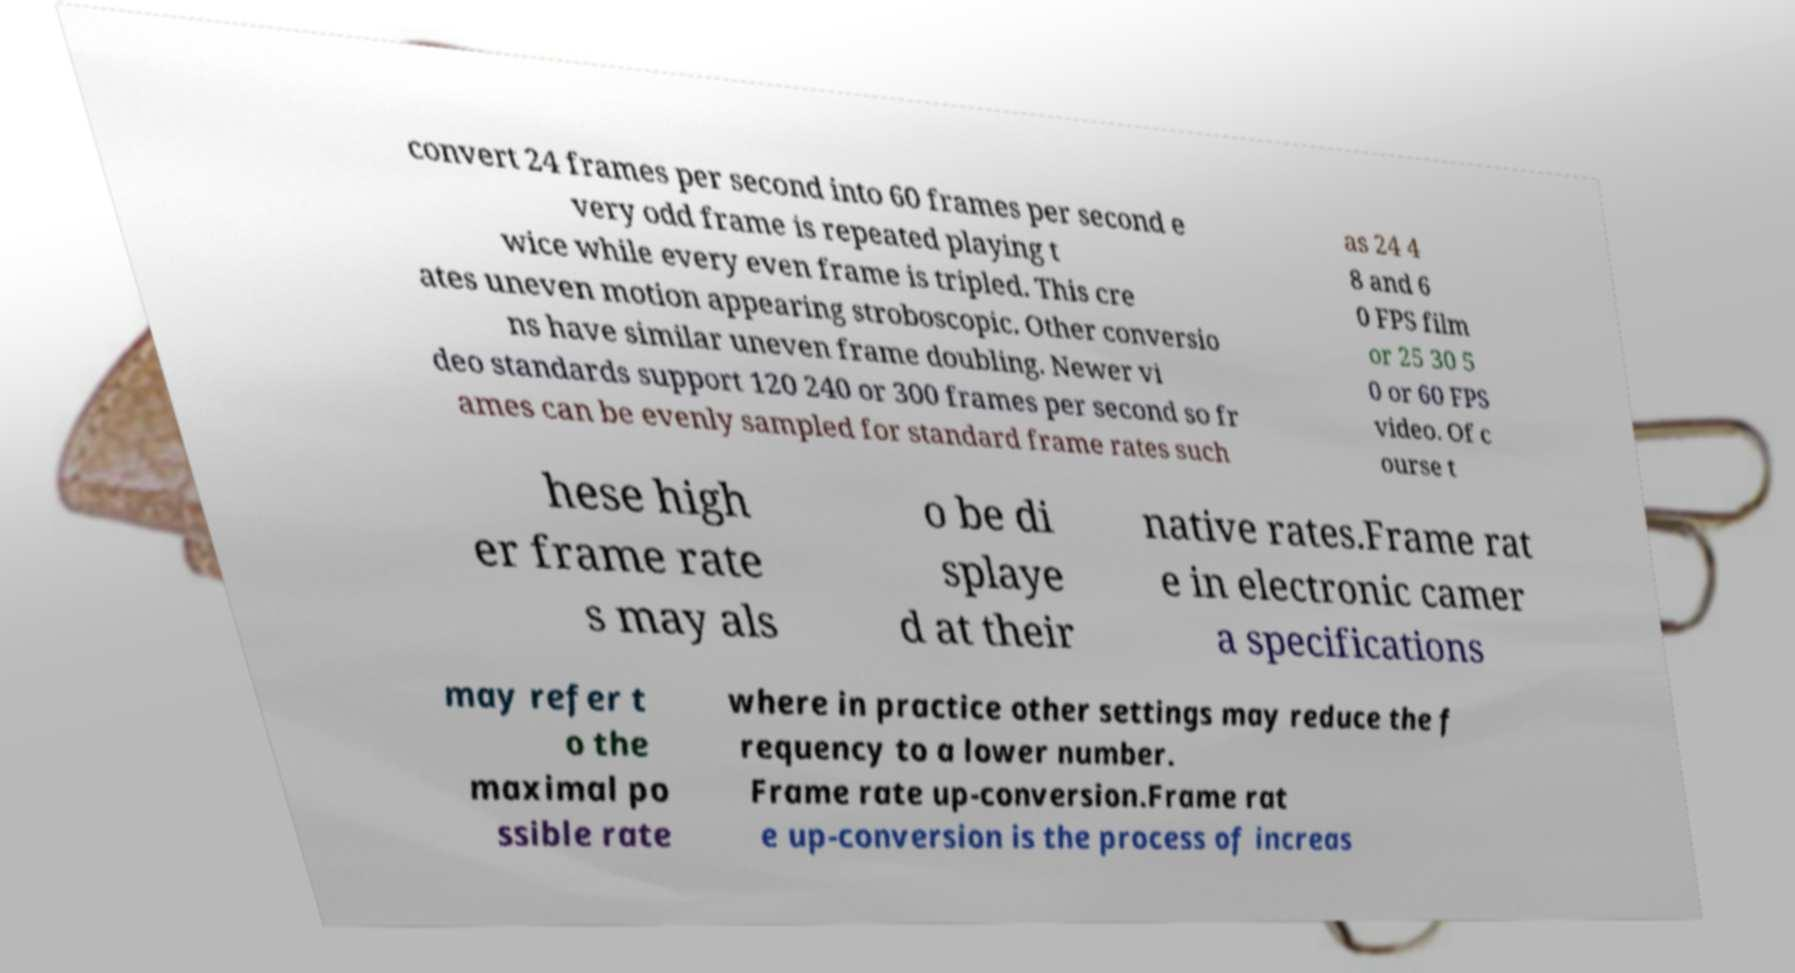Please read and relay the text visible in this image. What does it say? convert 24 frames per second into 60 frames per second e very odd frame is repeated playing t wice while every even frame is tripled. This cre ates uneven motion appearing stroboscopic. Other conversio ns have similar uneven frame doubling. Newer vi deo standards support 120 240 or 300 frames per second so fr ames can be evenly sampled for standard frame rates such as 24 4 8 and 6 0 FPS film or 25 30 5 0 or 60 FPS video. Of c ourse t hese high er frame rate s may als o be di splaye d at their native rates.Frame rat e in electronic camer a specifications may refer t o the maximal po ssible rate where in practice other settings may reduce the f requency to a lower number. Frame rate up-conversion.Frame rat e up-conversion is the process of increas 